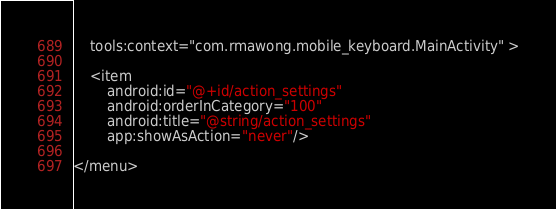<code> <loc_0><loc_0><loc_500><loc_500><_XML_>    tools:context="com.rmawong.mobile_keyboard.MainActivity" >

    <item
        android:id="@+id/action_settings"
        android:orderInCategory="100"
        android:title="@string/action_settings"
        app:showAsAction="never"/>

</menu>
</code> 